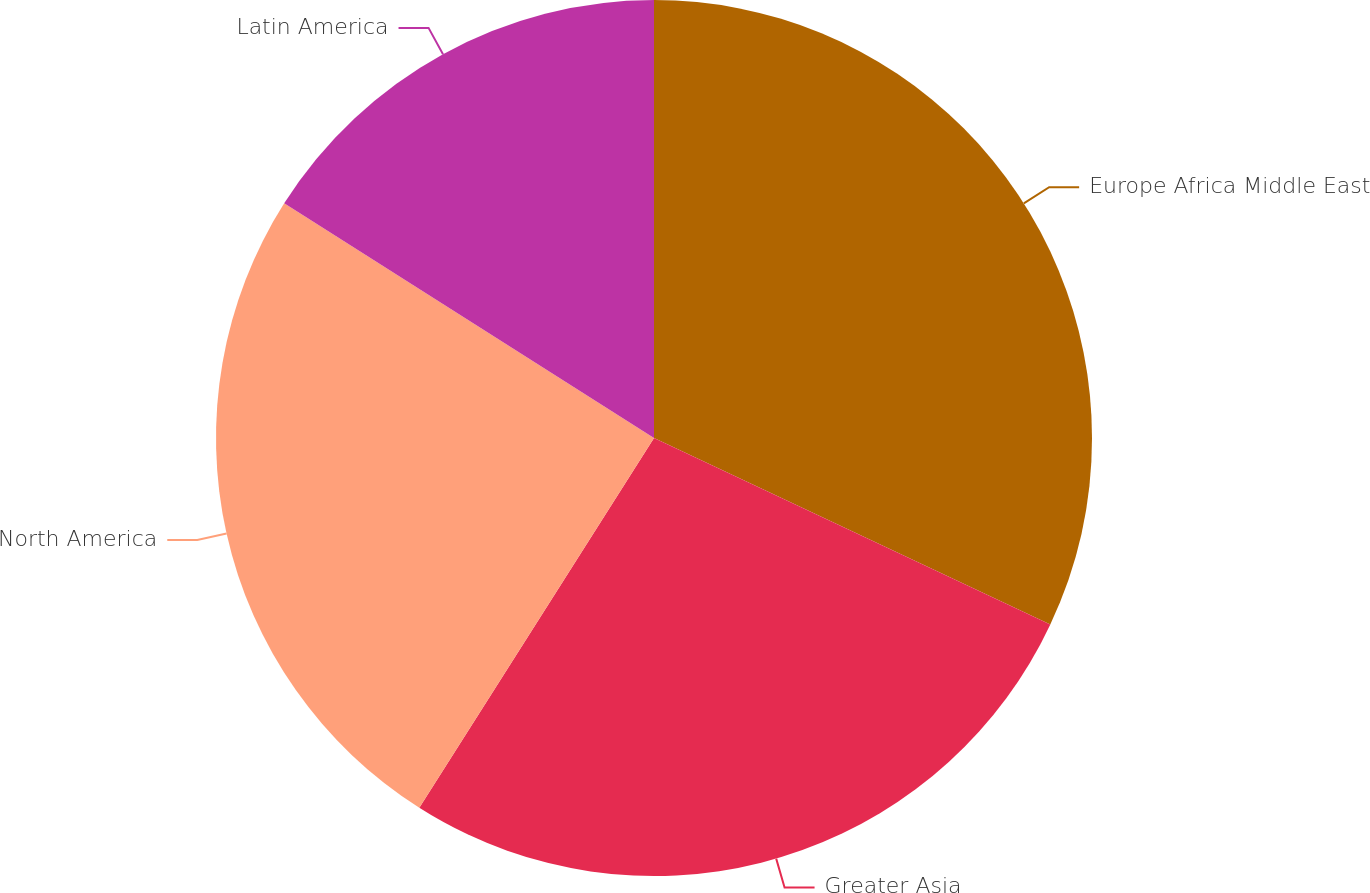Convert chart to OTSL. <chart><loc_0><loc_0><loc_500><loc_500><pie_chart><fcel>Europe Africa Middle East<fcel>Greater Asia<fcel>North America<fcel>Latin America<nl><fcel>32.0%<fcel>27.0%<fcel>25.0%<fcel>16.0%<nl></chart> 